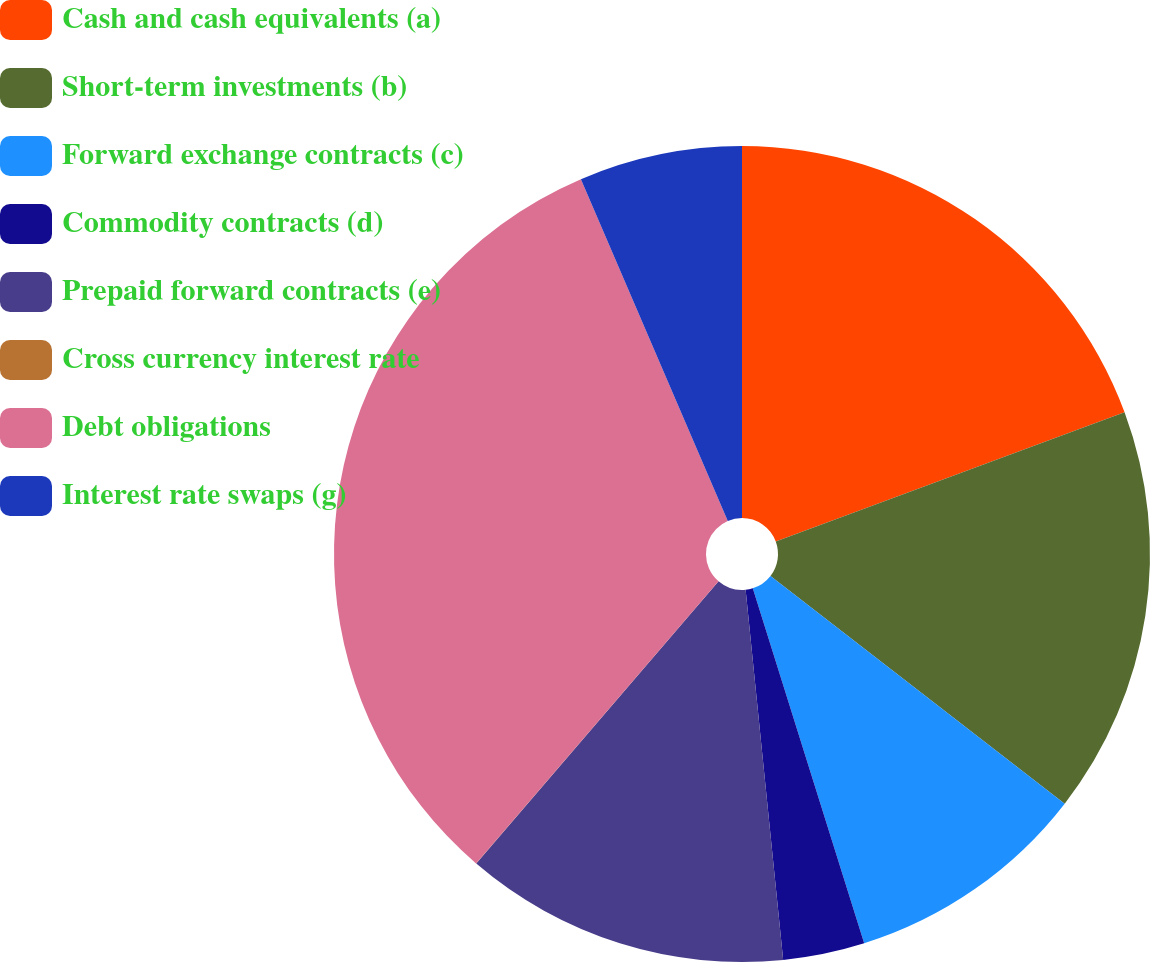Convert chart. <chart><loc_0><loc_0><loc_500><loc_500><pie_chart><fcel>Cash and cash equivalents (a)<fcel>Short-term investments (b)<fcel>Forward exchange contracts (c)<fcel>Commodity contracts (d)<fcel>Prepaid forward contracts (e)<fcel>Cross currency interest rate<fcel>Debt obligations<fcel>Interest rate swaps (g)<nl><fcel>19.35%<fcel>16.13%<fcel>9.68%<fcel>3.23%<fcel>12.9%<fcel>0.01%<fcel>32.24%<fcel>6.46%<nl></chart> 